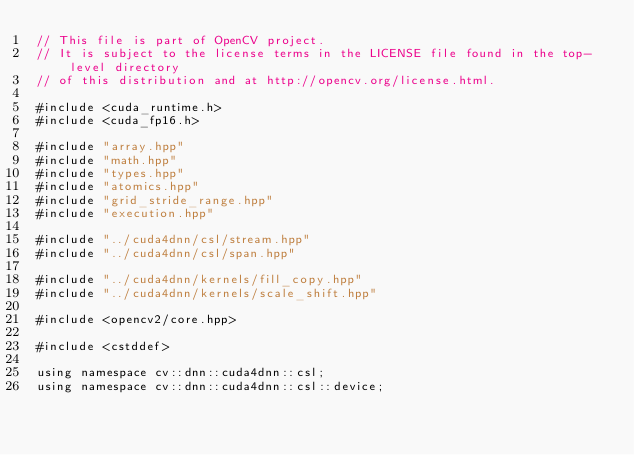Convert code to text. <code><loc_0><loc_0><loc_500><loc_500><_Cuda_>// This file is part of OpenCV project.
// It is subject to the license terms in the LICENSE file found in the top-level directory
// of this distribution and at http://opencv.org/license.html.

#include <cuda_runtime.h>
#include <cuda_fp16.h>

#include "array.hpp"
#include "math.hpp"
#include "types.hpp"
#include "atomics.hpp"
#include "grid_stride_range.hpp"
#include "execution.hpp"

#include "../cuda4dnn/csl/stream.hpp"
#include "../cuda4dnn/csl/span.hpp"

#include "../cuda4dnn/kernels/fill_copy.hpp"
#include "../cuda4dnn/kernels/scale_shift.hpp"

#include <opencv2/core.hpp>

#include <cstddef>

using namespace cv::dnn::cuda4dnn::csl;
using namespace cv::dnn::cuda4dnn::csl::device;
</code> 